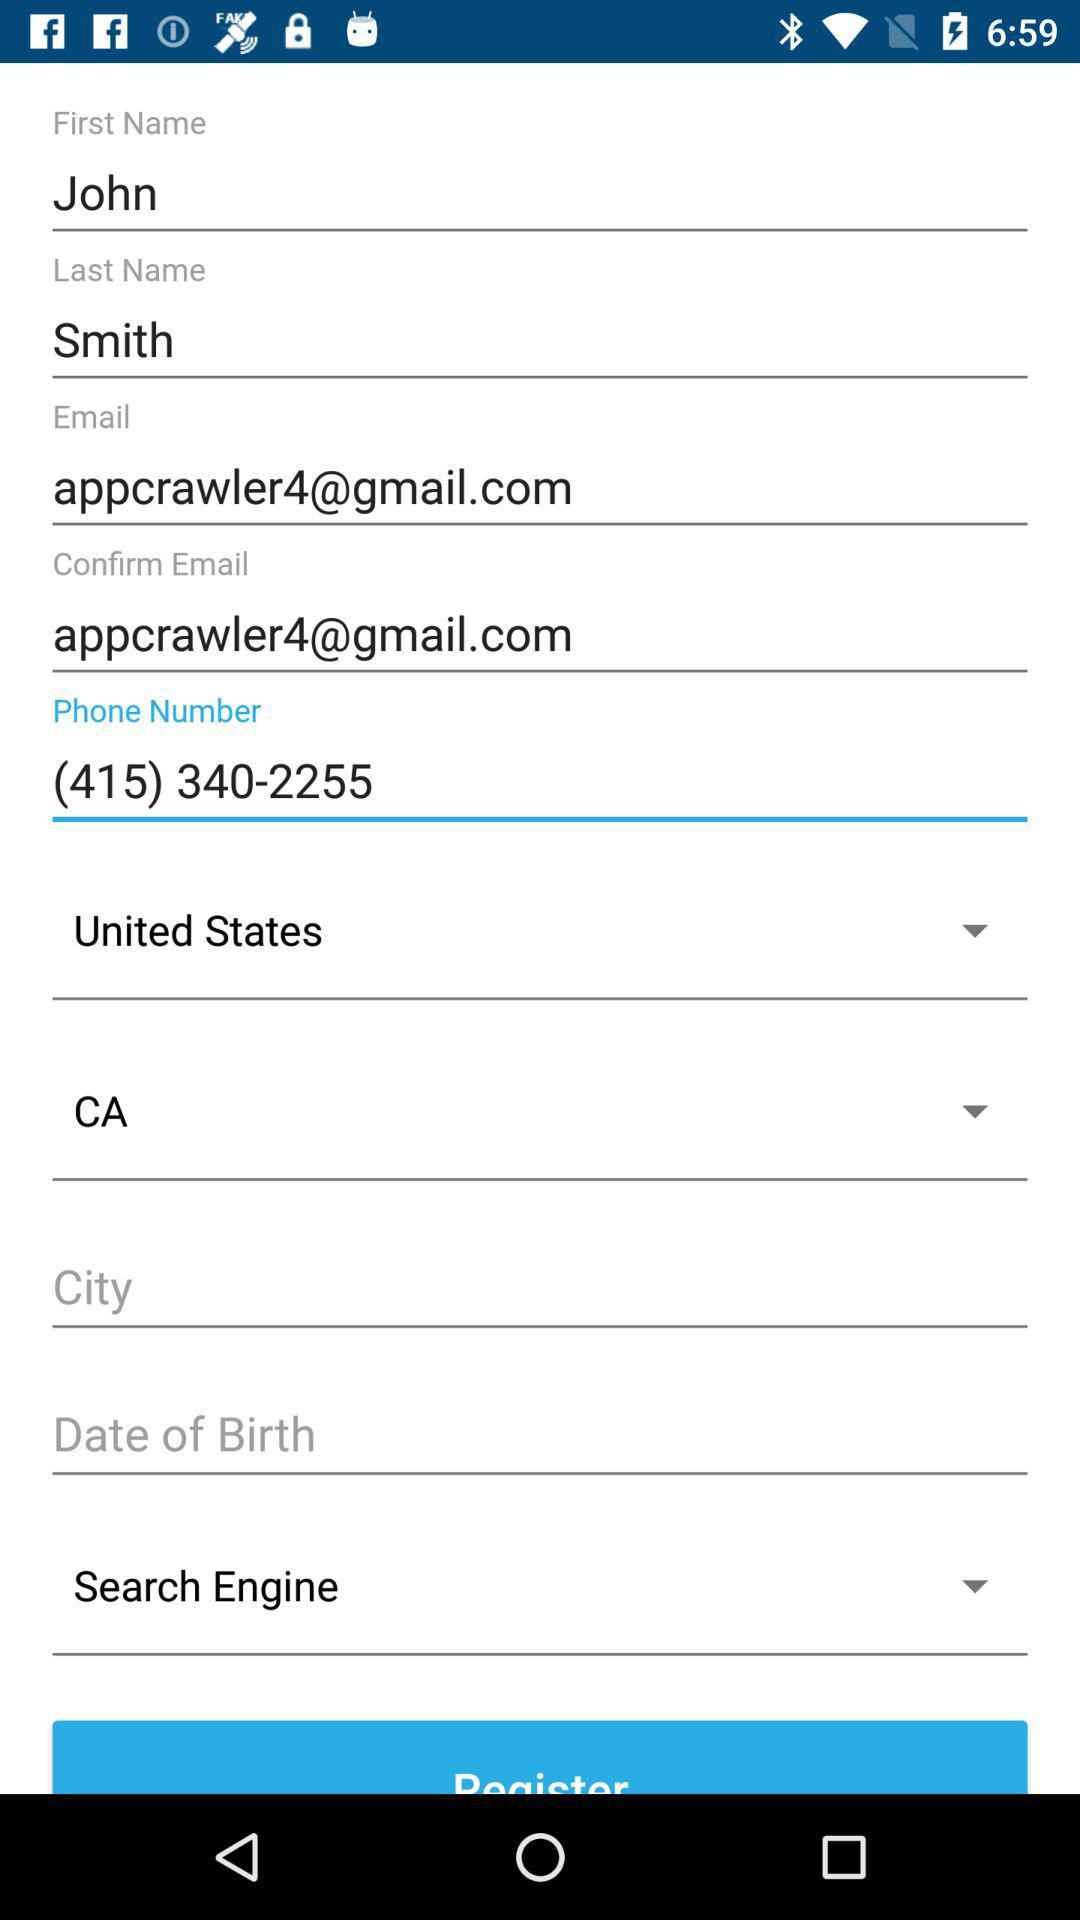What is the first name? The first name is John. 